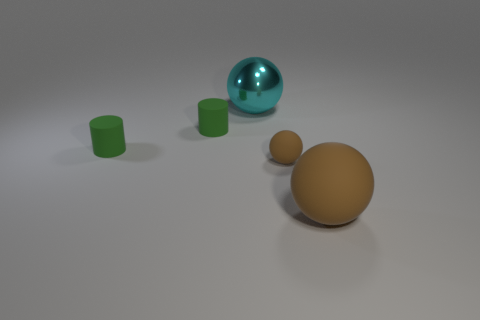Is there a small rubber thing of the same color as the large matte sphere?
Provide a succinct answer. Yes. What is the material of the tiny ball that is the same color as the large rubber sphere?
Make the answer very short. Rubber. How big is the brown ball in front of the brown matte ball that is on the left side of the large brown thing?
Provide a short and direct response. Large. How many big things are cyan metal spheres or matte spheres?
Your answer should be compact. 2. Are there fewer big brown spheres than big shiny cubes?
Ensure brevity in your answer.  No. Does the small sphere have the same color as the large matte ball?
Your response must be concise. Yes. Is the number of tiny brown metallic objects greater than the number of balls?
Provide a short and direct response. No. What number of other things are there of the same color as the large metallic sphere?
Provide a short and direct response. 0. How many large things are to the left of the big ball that is in front of the large cyan shiny object?
Give a very brief answer. 1. Are there any green rubber cylinders to the right of the cyan metallic object?
Offer a very short reply. No. 